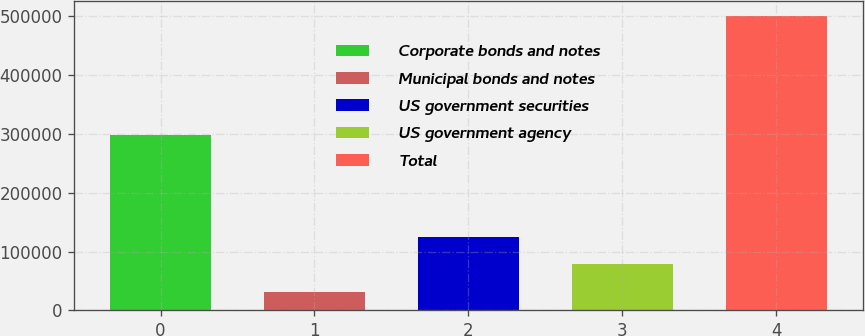Convert chart. <chart><loc_0><loc_0><loc_500><loc_500><bar_chart><fcel>Corporate bonds and notes<fcel>Municipal bonds and notes<fcel>US government securities<fcel>US government agency<fcel>Total<nl><fcel>298253<fcel>31137<fcel>124823<fcel>77979.8<fcel>499565<nl></chart> 